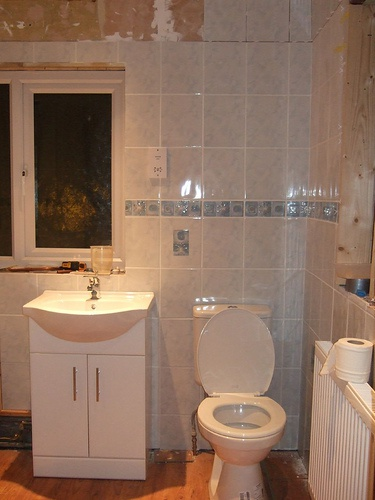Describe the objects in this image and their specific colors. I can see toilet in maroon, tan, and gray tones, sink in maroon, gray, khaki, tan, and lightyellow tones, and cup in maroon and tan tones in this image. 